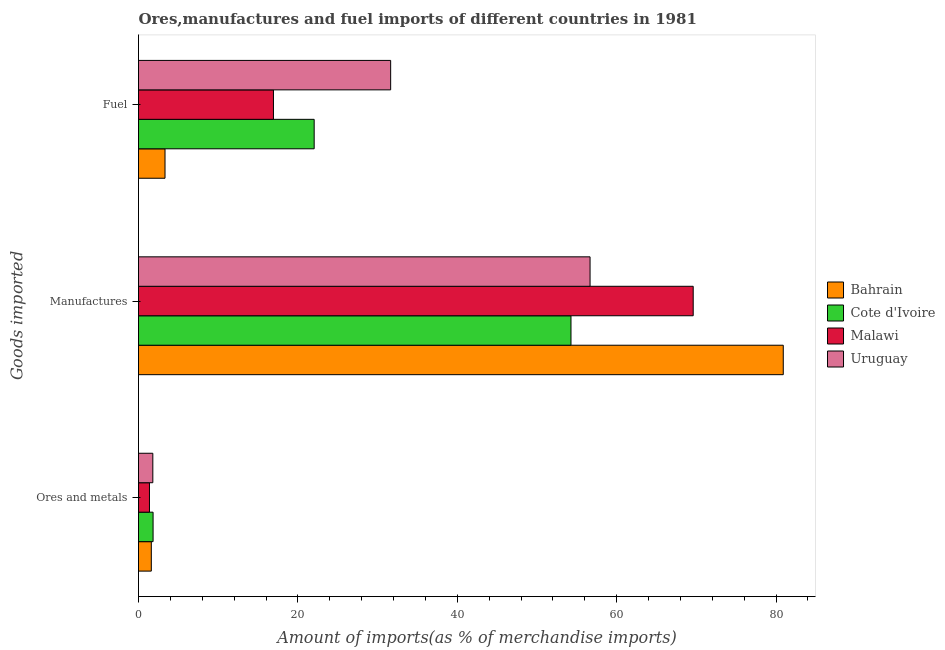How many different coloured bars are there?
Give a very brief answer. 4. How many groups of bars are there?
Ensure brevity in your answer.  3. Are the number of bars on each tick of the Y-axis equal?
Offer a terse response. Yes. How many bars are there on the 3rd tick from the top?
Give a very brief answer. 4. How many bars are there on the 2nd tick from the bottom?
Offer a very short reply. 4. What is the label of the 1st group of bars from the top?
Offer a terse response. Fuel. What is the percentage of manufactures imports in Cote d'Ivoire?
Provide a succinct answer. 54.27. Across all countries, what is the maximum percentage of manufactures imports?
Provide a short and direct response. 80.9. Across all countries, what is the minimum percentage of ores and metals imports?
Keep it short and to the point. 1.38. In which country was the percentage of ores and metals imports maximum?
Your answer should be compact. Cote d'Ivoire. In which country was the percentage of ores and metals imports minimum?
Your answer should be compact. Malawi. What is the total percentage of ores and metals imports in the graph?
Your response must be concise. 6.61. What is the difference between the percentage of ores and metals imports in Bahrain and that in Malawi?
Ensure brevity in your answer.  0.23. What is the difference between the percentage of fuel imports in Malawi and the percentage of ores and metals imports in Bahrain?
Give a very brief answer. 15.33. What is the average percentage of manufactures imports per country?
Give a very brief answer. 65.36. What is the difference between the percentage of manufactures imports and percentage of fuel imports in Cote d'Ivoire?
Your response must be concise. 32.22. In how many countries, is the percentage of manufactures imports greater than 68 %?
Offer a very short reply. 2. What is the ratio of the percentage of manufactures imports in Malawi to that in Uruguay?
Provide a short and direct response. 1.23. Is the percentage of fuel imports in Uruguay less than that in Malawi?
Provide a succinct answer. No. What is the difference between the highest and the second highest percentage of ores and metals imports?
Your answer should be compact. 0.03. What is the difference between the highest and the lowest percentage of ores and metals imports?
Provide a short and direct response. 0.45. In how many countries, is the percentage of manufactures imports greater than the average percentage of manufactures imports taken over all countries?
Your answer should be compact. 2. Is the sum of the percentage of manufactures imports in Uruguay and Cote d'Ivoire greater than the maximum percentage of fuel imports across all countries?
Your answer should be compact. Yes. What does the 3rd bar from the top in Ores and metals represents?
Offer a terse response. Cote d'Ivoire. What does the 4th bar from the bottom in Ores and metals represents?
Keep it short and to the point. Uruguay. How many countries are there in the graph?
Provide a short and direct response. 4. Are the values on the major ticks of X-axis written in scientific E-notation?
Your answer should be compact. No. Does the graph contain any zero values?
Ensure brevity in your answer.  No. Does the graph contain grids?
Make the answer very short. No. How many legend labels are there?
Your response must be concise. 4. What is the title of the graph?
Your answer should be very brief. Ores,manufactures and fuel imports of different countries in 1981. Does "Tunisia" appear as one of the legend labels in the graph?
Offer a terse response. No. What is the label or title of the X-axis?
Make the answer very short. Amount of imports(as % of merchandise imports). What is the label or title of the Y-axis?
Make the answer very short. Goods imported. What is the Amount of imports(as % of merchandise imports) of Bahrain in Ores and metals?
Provide a short and direct response. 1.61. What is the Amount of imports(as % of merchandise imports) in Cote d'Ivoire in Ores and metals?
Your response must be concise. 1.83. What is the Amount of imports(as % of merchandise imports) in Malawi in Ores and metals?
Your answer should be very brief. 1.38. What is the Amount of imports(as % of merchandise imports) in Uruguay in Ores and metals?
Offer a very short reply. 1.8. What is the Amount of imports(as % of merchandise imports) in Bahrain in Manufactures?
Offer a very short reply. 80.9. What is the Amount of imports(as % of merchandise imports) in Cote d'Ivoire in Manufactures?
Make the answer very short. 54.27. What is the Amount of imports(as % of merchandise imports) in Malawi in Manufactures?
Keep it short and to the point. 69.6. What is the Amount of imports(as % of merchandise imports) of Uruguay in Manufactures?
Ensure brevity in your answer.  56.66. What is the Amount of imports(as % of merchandise imports) in Bahrain in Fuel?
Provide a succinct answer. 3.33. What is the Amount of imports(as % of merchandise imports) of Cote d'Ivoire in Fuel?
Give a very brief answer. 22.04. What is the Amount of imports(as % of merchandise imports) of Malawi in Fuel?
Keep it short and to the point. 16.93. What is the Amount of imports(as % of merchandise imports) of Uruguay in Fuel?
Give a very brief answer. 31.64. Across all Goods imported, what is the maximum Amount of imports(as % of merchandise imports) in Bahrain?
Make the answer very short. 80.9. Across all Goods imported, what is the maximum Amount of imports(as % of merchandise imports) of Cote d'Ivoire?
Provide a short and direct response. 54.27. Across all Goods imported, what is the maximum Amount of imports(as % of merchandise imports) in Malawi?
Your answer should be compact. 69.6. Across all Goods imported, what is the maximum Amount of imports(as % of merchandise imports) in Uruguay?
Your answer should be compact. 56.66. Across all Goods imported, what is the minimum Amount of imports(as % of merchandise imports) in Bahrain?
Offer a very short reply. 1.61. Across all Goods imported, what is the minimum Amount of imports(as % of merchandise imports) of Cote d'Ivoire?
Offer a very short reply. 1.83. Across all Goods imported, what is the minimum Amount of imports(as % of merchandise imports) of Malawi?
Give a very brief answer. 1.38. Across all Goods imported, what is the minimum Amount of imports(as % of merchandise imports) of Uruguay?
Give a very brief answer. 1.8. What is the total Amount of imports(as % of merchandise imports) of Bahrain in the graph?
Make the answer very short. 85.84. What is the total Amount of imports(as % of merchandise imports) in Cote d'Ivoire in the graph?
Your answer should be very brief. 78.14. What is the total Amount of imports(as % of merchandise imports) in Malawi in the graph?
Ensure brevity in your answer.  87.91. What is the total Amount of imports(as % of merchandise imports) of Uruguay in the graph?
Give a very brief answer. 90.1. What is the difference between the Amount of imports(as % of merchandise imports) in Bahrain in Ores and metals and that in Manufactures?
Your response must be concise. -79.3. What is the difference between the Amount of imports(as % of merchandise imports) of Cote d'Ivoire in Ores and metals and that in Manufactures?
Your answer should be very brief. -52.44. What is the difference between the Amount of imports(as % of merchandise imports) of Malawi in Ores and metals and that in Manufactures?
Offer a very short reply. -68.23. What is the difference between the Amount of imports(as % of merchandise imports) in Uruguay in Ores and metals and that in Manufactures?
Your answer should be compact. -54.86. What is the difference between the Amount of imports(as % of merchandise imports) in Bahrain in Ores and metals and that in Fuel?
Give a very brief answer. -1.72. What is the difference between the Amount of imports(as % of merchandise imports) of Cote d'Ivoire in Ores and metals and that in Fuel?
Your answer should be very brief. -20.21. What is the difference between the Amount of imports(as % of merchandise imports) in Malawi in Ores and metals and that in Fuel?
Give a very brief answer. -15.56. What is the difference between the Amount of imports(as % of merchandise imports) in Uruguay in Ores and metals and that in Fuel?
Provide a short and direct response. -29.84. What is the difference between the Amount of imports(as % of merchandise imports) of Bahrain in Manufactures and that in Fuel?
Your answer should be compact. 77.58. What is the difference between the Amount of imports(as % of merchandise imports) of Cote d'Ivoire in Manufactures and that in Fuel?
Your answer should be very brief. 32.22. What is the difference between the Amount of imports(as % of merchandise imports) in Malawi in Manufactures and that in Fuel?
Your response must be concise. 52.67. What is the difference between the Amount of imports(as % of merchandise imports) of Uruguay in Manufactures and that in Fuel?
Ensure brevity in your answer.  25.02. What is the difference between the Amount of imports(as % of merchandise imports) of Bahrain in Ores and metals and the Amount of imports(as % of merchandise imports) of Cote d'Ivoire in Manufactures?
Provide a succinct answer. -52.66. What is the difference between the Amount of imports(as % of merchandise imports) in Bahrain in Ores and metals and the Amount of imports(as % of merchandise imports) in Malawi in Manufactures?
Ensure brevity in your answer.  -67.99. What is the difference between the Amount of imports(as % of merchandise imports) in Bahrain in Ores and metals and the Amount of imports(as % of merchandise imports) in Uruguay in Manufactures?
Keep it short and to the point. -55.05. What is the difference between the Amount of imports(as % of merchandise imports) in Cote d'Ivoire in Ores and metals and the Amount of imports(as % of merchandise imports) in Malawi in Manufactures?
Give a very brief answer. -67.77. What is the difference between the Amount of imports(as % of merchandise imports) of Cote d'Ivoire in Ores and metals and the Amount of imports(as % of merchandise imports) of Uruguay in Manufactures?
Provide a succinct answer. -54.83. What is the difference between the Amount of imports(as % of merchandise imports) of Malawi in Ores and metals and the Amount of imports(as % of merchandise imports) of Uruguay in Manufactures?
Provide a succinct answer. -55.28. What is the difference between the Amount of imports(as % of merchandise imports) in Bahrain in Ores and metals and the Amount of imports(as % of merchandise imports) in Cote d'Ivoire in Fuel?
Your response must be concise. -20.44. What is the difference between the Amount of imports(as % of merchandise imports) in Bahrain in Ores and metals and the Amount of imports(as % of merchandise imports) in Malawi in Fuel?
Keep it short and to the point. -15.33. What is the difference between the Amount of imports(as % of merchandise imports) in Bahrain in Ores and metals and the Amount of imports(as % of merchandise imports) in Uruguay in Fuel?
Provide a short and direct response. -30.03. What is the difference between the Amount of imports(as % of merchandise imports) of Cote d'Ivoire in Ores and metals and the Amount of imports(as % of merchandise imports) of Malawi in Fuel?
Provide a short and direct response. -15.1. What is the difference between the Amount of imports(as % of merchandise imports) in Cote d'Ivoire in Ores and metals and the Amount of imports(as % of merchandise imports) in Uruguay in Fuel?
Your answer should be compact. -29.81. What is the difference between the Amount of imports(as % of merchandise imports) in Malawi in Ores and metals and the Amount of imports(as % of merchandise imports) in Uruguay in Fuel?
Give a very brief answer. -30.26. What is the difference between the Amount of imports(as % of merchandise imports) of Bahrain in Manufactures and the Amount of imports(as % of merchandise imports) of Cote d'Ivoire in Fuel?
Your response must be concise. 58.86. What is the difference between the Amount of imports(as % of merchandise imports) of Bahrain in Manufactures and the Amount of imports(as % of merchandise imports) of Malawi in Fuel?
Your answer should be compact. 63.97. What is the difference between the Amount of imports(as % of merchandise imports) in Bahrain in Manufactures and the Amount of imports(as % of merchandise imports) in Uruguay in Fuel?
Ensure brevity in your answer.  49.26. What is the difference between the Amount of imports(as % of merchandise imports) of Cote d'Ivoire in Manufactures and the Amount of imports(as % of merchandise imports) of Malawi in Fuel?
Keep it short and to the point. 37.33. What is the difference between the Amount of imports(as % of merchandise imports) in Cote d'Ivoire in Manufactures and the Amount of imports(as % of merchandise imports) in Uruguay in Fuel?
Keep it short and to the point. 22.63. What is the difference between the Amount of imports(as % of merchandise imports) of Malawi in Manufactures and the Amount of imports(as % of merchandise imports) of Uruguay in Fuel?
Your answer should be compact. 37.96. What is the average Amount of imports(as % of merchandise imports) of Bahrain per Goods imported?
Your response must be concise. 28.61. What is the average Amount of imports(as % of merchandise imports) of Cote d'Ivoire per Goods imported?
Offer a terse response. 26.05. What is the average Amount of imports(as % of merchandise imports) in Malawi per Goods imported?
Your answer should be compact. 29.3. What is the average Amount of imports(as % of merchandise imports) in Uruguay per Goods imported?
Give a very brief answer. 30.03. What is the difference between the Amount of imports(as % of merchandise imports) of Bahrain and Amount of imports(as % of merchandise imports) of Cote d'Ivoire in Ores and metals?
Ensure brevity in your answer.  -0.22. What is the difference between the Amount of imports(as % of merchandise imports) of Bahrain and Amount of imports(as % of merchandise imports) of Malawi in Ores and metals?
Offer a terse response. 0.23. What is the difference between the Amount of imports(as % of merchandise imports) of Bahrain and Amount of imports(as % of merchandise imports) of Uruguay in Ores and metals?
Your response must be concise. -0.19. What is the difference between the Amount of imports(as % of merchandise imports) of Cote d'Ivoire and Amount of imports(as % of merchandise imports) of Malawi in Ores and metals?
Ensure brevity in your answer.  0.45. What is the difference between the Amount of imports(as % of merchandise imports) in Cote d'Ivoire and Amount of imports(as % of merchandise imports) in Uruguay in Ores and metals?
Give a very brief answer. 0.03. What is the difference between the Amount of imports(as % of merchandise imports) in Malawi and Amount of imports(as % of merchandise imports) in Uruguay in Ores and metals?
Your answer should be compact. -0.42. What is the difference between the Amount of imports(as % of merchandise imports) in Bahrain and Amount of imports(as % of merchandise imports) in Cote d'Ivoire in Manufactures?
Your response must be concise. 26.64. What is the difference between the Amount of imports(as % of merchandise imports) of Bahrain and Amount of imports(as % of merchandise imports) of Malawi in Manufactures?
Your response must be concise. 11.3. What is the difference between the Amount of imports(as % of merchandise imports) of Bahrain and Amount of imports(as % of merchandise imports) of Uruguay in Manufactures?
Make the answer very short. 24.24. What is the difference between the Amount of imports(as % of merchandise imports) of Cote d'Ivoire and Amount of imports(as % of merchandise imports) of Malawi in Manufactures?
Your answer should be very brief. -15.33. What is the difference between the Amount of imports(as % of merchandise imports) in Cote d'Ivoire and Amount of imports(as % of merchandise imports) in Uruguay in Manufactures?
Your response must be concise. -2.39. What is the difference between the Amount of imports(as % of merchandise imports) of Malawi and Amount of imports(as % of merchandise imports) of Uruguay in Manufactures?
Your response must be concise. 12.94. What is the difference between the Amount of imports(as % of merchandise imports) in Bahrain and Amount of imports(as % of merchandise imports) in Cote d'Ivoire in Fuel?
Offer a terse response. -18.72. What is the difference between the Amount of imports(as % of merchandise imports) of Bahrain and Amount of imports(as % of merchandise imports) of Malawi in Fuel?
Offer a very short reply. -13.61. What is the difference between the Amount of imports(as % of merchandise imports) of Bahrain and Amount of imports(as % of merchandise imports) of Uruguay in Fuel?
Your response must be concise. -28.31. What is the difference between the Amount of imports(as % of merchandise imports) of Cote d'Ivoire and Amount of imports(as % of merchandise imports) of Malawi in Fuel?
Provide a succinct answer. 5.11. What is the difference between the Amount of imports(as % of merchandise imports) of Cote d'Ivoire and Amount of imports(as % of merchandise imports) of Uruguay in Fuel?
Ensure brevity in your answer.  -9.6. What is the difference between the Amount of imports(as % of merchandise imports) in Malawi and Amount of imports(as % of merchandise imports) in Uruguay in Fuel?
Make the answer very short. -14.71. What is the ratio of the Amount of imports(as % of merchandise imports) of Bahrain in Ores and metals to that in Manufactures?
Your response must be concise. 0.02. What is the ratio of the Amount of imports(as % of merchandise imports) of Cote d'Ivoire in Ores and metals to that in Manufactures?
Your answer should be very brief. 0.03. What is the ratio of the Amount of imports(as % of merchandise imports) in Malawi in Ores and metals to that in Manufactures?
Make the answer very short. 0.02. What is the ratio of the Amount of imports(as % of merchandise imports) of Uruguay in Ores and metals to that in Manufactures?
Ensure brevity in your answer.  0.03. What is the ratio of the Amount of imports(as % of merchandise imports) of Bahrain in Ores and metals to that in Fuel?
Make the answer very short. 0.48. What is the ratio of the Amount of imports(as % of merchandise imports) in Cote d'Ivoire in Ores and metals to that in Fuel?
Provide a succinct answer. 0.08. What is the ratio of the Amount of imports(as % of merchandise imports) of Malawi in Ores and metals to that in Fuel?
Keep it short and to the point. 0.08. What is the ratio of the Amount of imports(as % of merchandise imports) in Uruguay in Ores and metals to that in Fuel?
Provide a short and direct response. 0.06. What is the ratio of the Amount of imports(as % of merchandise imports) of Bahrain in Manufactures to that in Fuel?
Keep it short and to the point. 24.33. What is the ratio of the Amount of imports(as % of merchandise imports) in Cote d'Ivoire in Manufactures to that in Fuel?
Ensure brevity in your answer.  2.46. What is the ratio of the Amount of imports(as % of merchandise imports) in Malawi in Manufactures to that in Fuel?
Make the answer very short. 4.11. What is the ratio of the Amount of imports(as % of merchandise imports) of Uruguay in Manufactures to that in Fuel?
Give a very brief answer. 1.79. What is the difference between the highest and the second highest Amount of imports(as % of merchandise imports) in Bahrain?
Make the answer very short. 77.58. What is the difference between the highest and the second highest Amount of imports(as % of merchandise imports) of Cote d'Ivoire?
Your response must be concise. 32.22. What is the difference between the highest and the second highest Amount of imports(as % of merchandise imports) of Malawi?
Make the answer very short. 52.67. What is the difference between the highest and the second highest Amount of imports(as % of merchandise imports) in Uruguay?
Offer a very short reply. 25.02. What is the difference between the highest and the lowest Amount of imports(as % of merchandise imports) of Bahrain?
Give a very brief answer. 79.3. What is the difference between the highest and the lowest Amount of imports(as % of merchandise imports) in Cote d'Ivoire?
Offer a very short reply. 52.44. What is the difference between the highest and the lowest Amount of imports(as % of merchandise imports) in Malawi?
Provide a succinct answer. 68.23. What is the difference between the highest and the lowest Amount of imports(as % of merchandise imports) of Uruguay?
Your response must be concise. 54.86. 